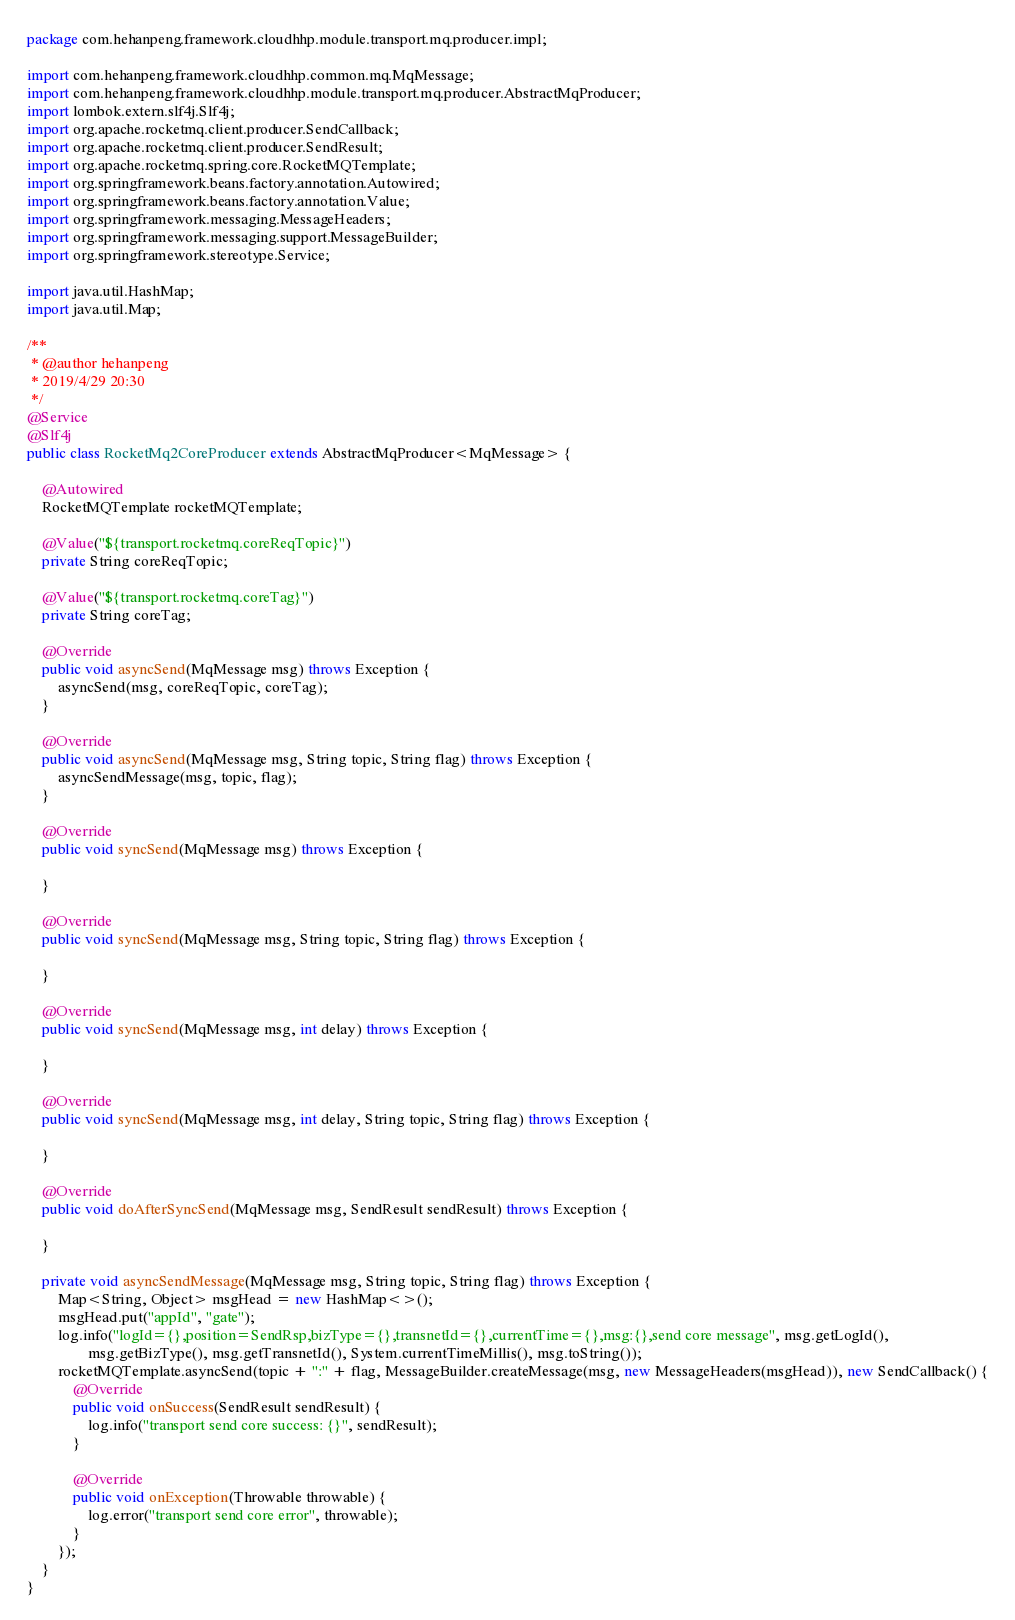<code> <loc_0><loc_0><loc_500><loc_500><_Java_>package com.hehanpeng.framework.cloudhhp.module.transport.mq.producer.impl;

import com.hehanpeng.framework.cloudhhp.common.mq.MqMessage;
import com.hehanpeng.framework.cloudhhp.module.transport.mq.producer.AbstractMqProducer;
import lombok.extern.slf4j.Slf4j;
import org.apache.rocketmq.client.producer.SendCallback;
import org.apache.rocketmq.client.producer.SendResult;
import org.apache.rocketmq.spring.core.RocketMQTemplate;
import org.springframework.beans.factory.annotation.Autowired;
import org.springframework.beans.factory.annotation.Value;
import org.springframework.messaging.MessageHeaders;
import org.springframework.messaging.support.MessageBuilder;
import org.springframework.stereotype.Service;

import java.util.HashMap;
import java.util.Map;

/**
 * @author hehanpeng
 * 2019/4/29 20:30
 */
@Service
@Slf4j
public class RocketMq2CoreProducer extends AbstractMqProducer<MqMessage> {

    @Autowired
    RocketMQTemplate rocketMQTemplate;

    @Value("${transport.rocketmq.coreReqTopic}")
    private String coreReqTopic;

    @Value("${transport.rocketmq.coreTag}")
    private String coreTag;

    @Override
    public void asyncSend(MqMessage msg) throws Exception {
        asyncSend(msg, coreReqTopic, coreTag);
    }

    @Override
    public void asyncSend(MqMessage msg, String topic, String flag) throws Exception {
        asyncSendMessage(msg, topic, flag);
    }

    @Override
    public void syncSend(MqMessage msg) throws Exception {

    }

    @Override
    public void syncSend(MqMessage msg, String topic, String flag) throws Exception {

    }

    @Override
    public void syncSend(MqMessage msg, int delay) throws Exception {

    }

    @Override
    public void syncSend(MqMessage msg, int delay, String topic, String flag) throws Exception {

    }

    @Override
    public void doAfterSyncSend(MqMessage msg, SendResult sendResult) throws Exception {

    }

    private void asyncSendMessage(MqMessage msg, String topic, String flag) throws Exception {
        Map<String, Object> msgHead = new HashMap<>();
        msgHead.put("appId", "gate");
        log.info("logId={},position=SendRsp,bizType={},transnetId={},currentTime={},msg:{},send core message", msg.getLogId(),
                msg.getBizType(), msg.getTransnetId(), System.currentTimeMillis(), msg.toString());
        rocketMQTemplate.asyncSend(topic + ":" + flag, MessageBuilder.createMessage(msg, new MessageHeaders(msgHead)), new SendCallback() {
            @Override
            public void onSuccess(SendResult sendResult) {
                log.info("transport send core success: {}", sendResult);
            }

            @Override
            public void onException(Throwable throwable) {
                log.error("transport send core error", throwable);
            }
        });
    }
}
</code> 